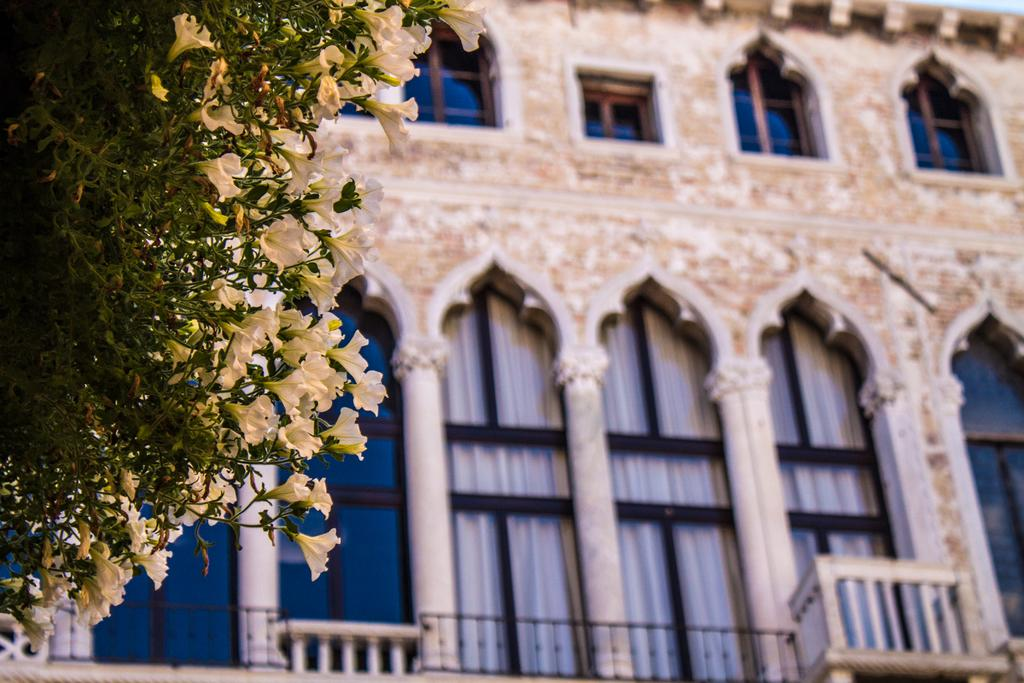What type of vegetation is on the left side of the image? There are plants with leaves and flowers on the left side of the image. What type of structure can be seen in the image? There is a building with windows visible in the image. What type of rose can be seen on the silk fabric in the image? There is no rose or silk fabric present in the image. Why is the person in the image crying while looking at the building? There is no person present in the image, so it is not possible to determine if anyone is crying or looking at the building. 